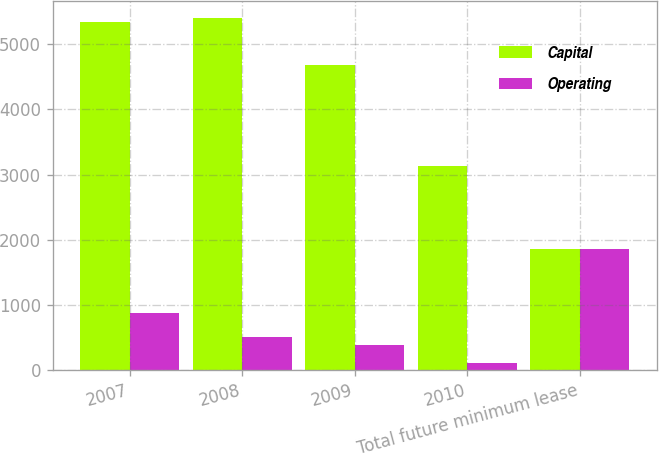<chart> <loc_0><loc_0><loc_500><loc_500><stacked_bar_chart><ecel><fcel>2007<fcel>2008<fcel>2009<fcel>2010<fcel>Total future minimum lease<nl><fcel>Capital<fcel>5340<fcel>5403<fcel>4690<fcel>3128<fcel>1859<nl><fcel>Operating<fcel>874<fcel>508<fcel>378<fcel>99<fcel>1859<nl></chart> 